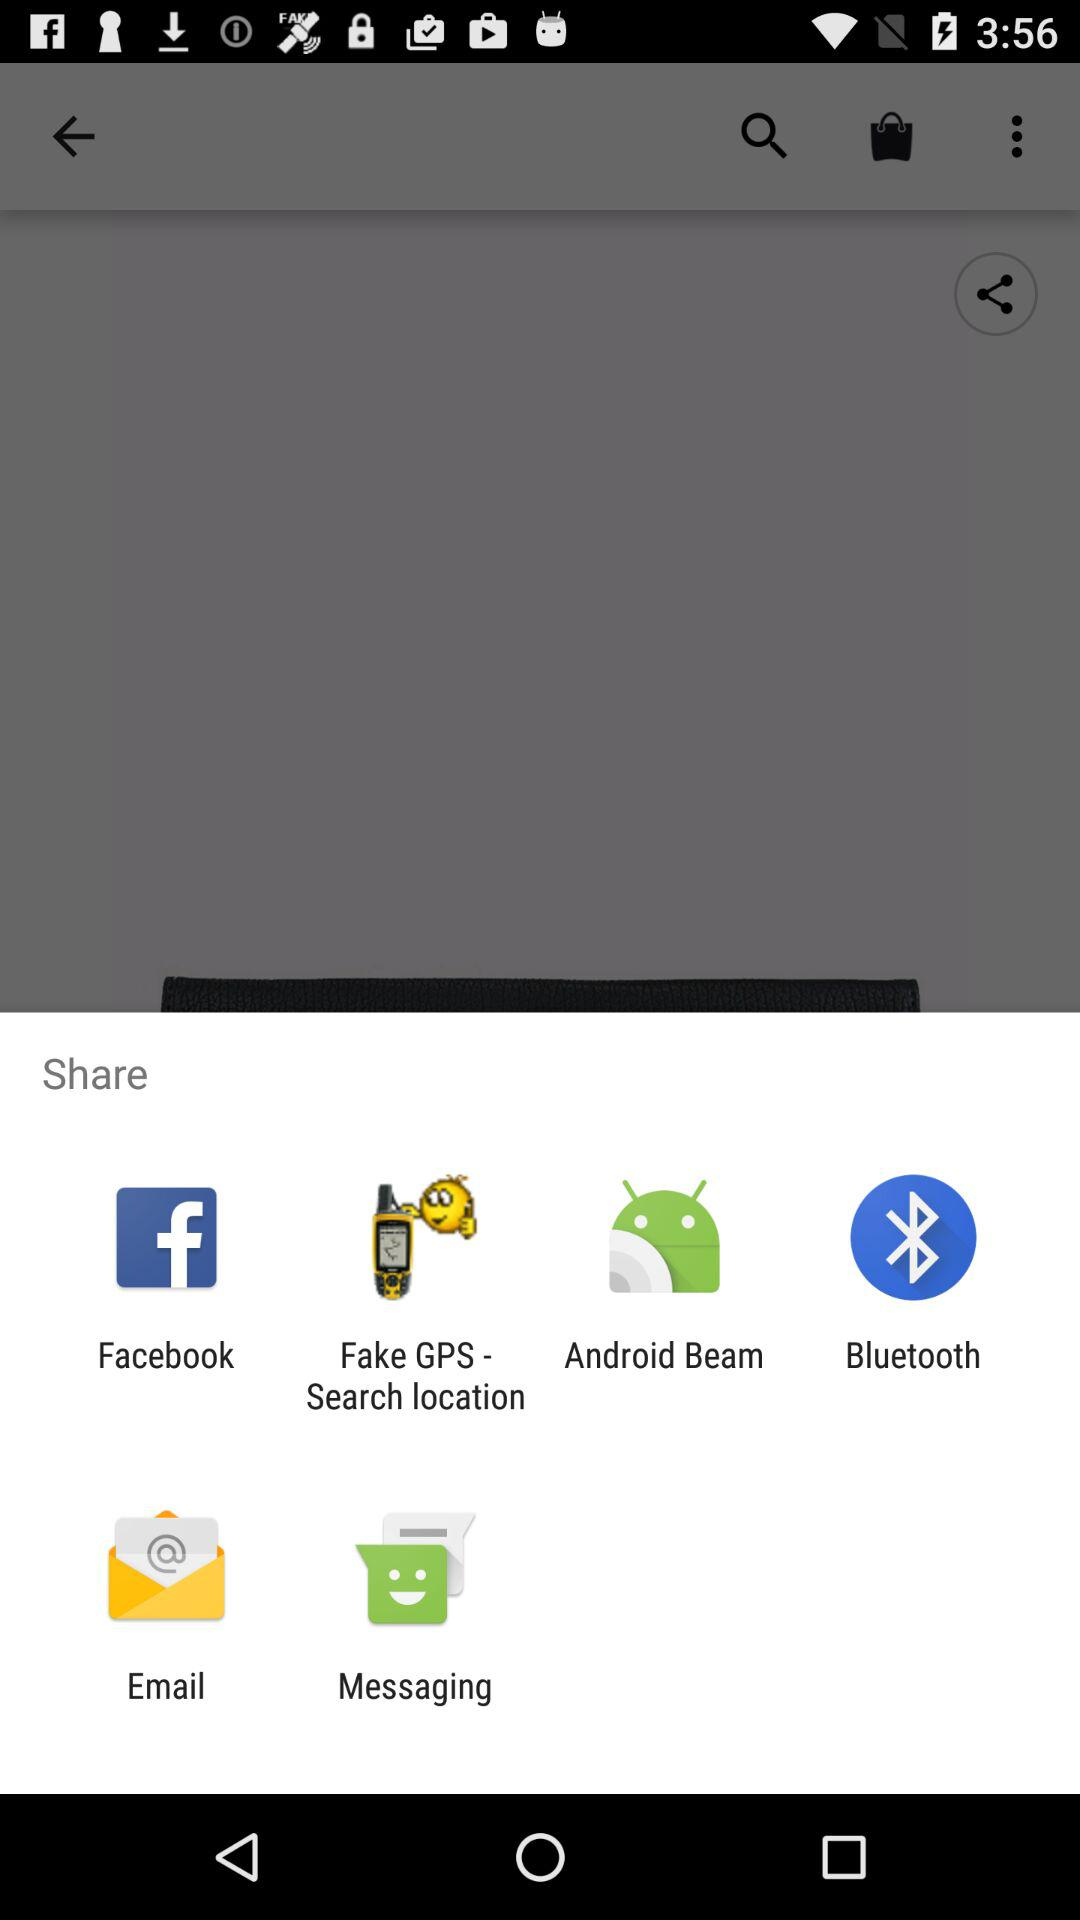How many items are in the basket?
When the provided information is insufficient, respond with <no answer>. <no answer> 